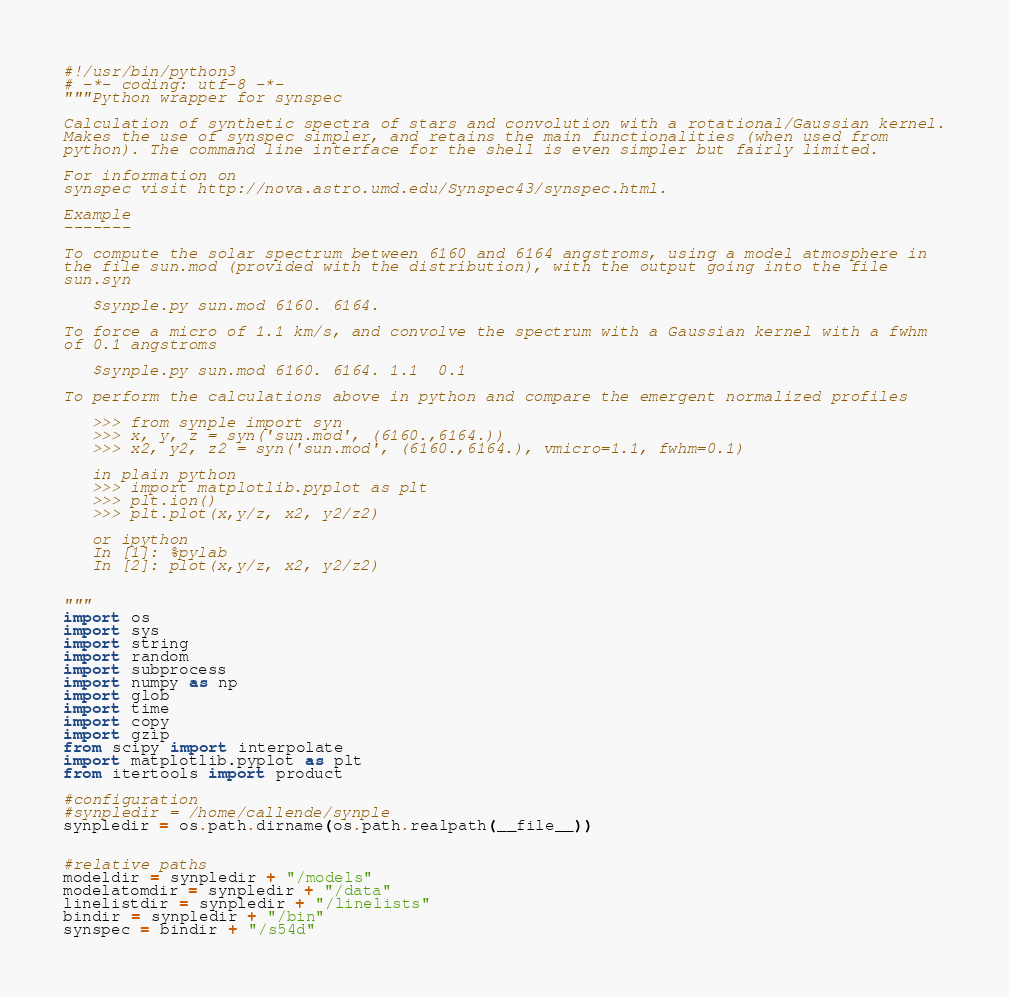Convert code to text. <code><loc_0><loc_0><loc_500><loc_500><_Python_>#!/usr/bin/python3
# -*- coding: utf-8 -*-
"""Python wrapper for synspec 

Calculation of synthetic spectra of stars and convolution with a rotational/Gaussian kernel.
Makes the use of synspec simpler, and retains the main functionalities (when used from
python). The command line interface for the shell is even simpler but fairly limited. 

For information on
synspec visit http://nova.astro.umd.edu/Synspec43/synspec.html.

Example
-------

To compute the solar spectrum between 6160 and 6164 angstroms, using a model atmosphere in
the file sun.mod (provided with the distribution), with the output going into the file
sun.syn

   $synple.py sun.mod 6160. 6164. 

To force a micro of 1.1 km/s, and convolve the spectrum with a Gaussian kernel with a fwhm 
of 0.1 angstroms

   $synple.py sun.mod 6160. 6164. 1.1  0.1

To perform the calculations above in python and compare the emergent normalized profiles

   >>> from synple import syn
   >>> x, y, z = syn('sun.mod', (6160.,6164.))
   >>> x2, y2, z2 = syn('sun.mod', (6160.,6164.), vmicro=1.1, fwhm=0.1)

   in plain python
   >>> import matplotlib.pyplot as plt
   >>> plt.ion()
   >>> plt.plot(x,y/z, x2, y2/z2)

   or ipython
   In [1]: %pylab
   In [2]: plot(x,y/z, x2, y2/z2)


"""
import os
import sys
import string
import random
import subprocess
import numpy as np
import glob
import time
import copy
import gzip
from scipy import interpolate
import matplotlib.pyplot as plt
from itertools import product

#configuration
#synpledir = /home/callende/synple
synpledir = os.path.dirname(os.path.realpath(__file__))


#relative paths
modeldir = synpledir + "/models"
modelatomdir = synpledir + "/data"
linelistdir = synpledir + "/linelists"
bindir = synpledir + "/bin"
synspec = bindir + "/s54d"</code> 